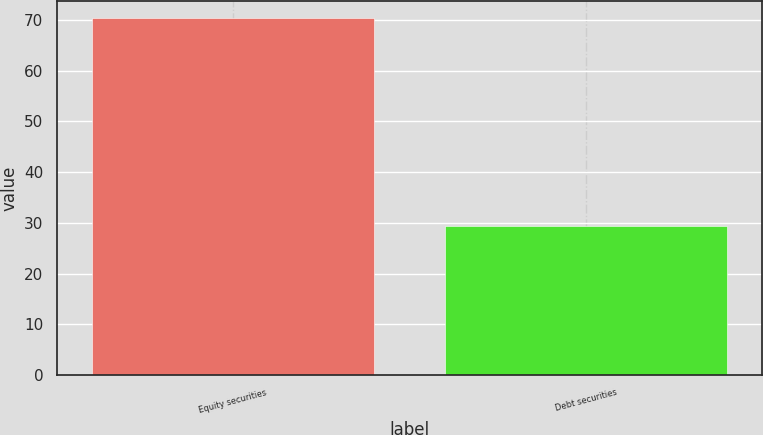<chart> <loc_0><loc_0><loc_500><loc_500><bar_chart><fcel>Equity securities<fcel>Debt securities<nl><fcel>70.3<fcel>29.4<nl></chart> 